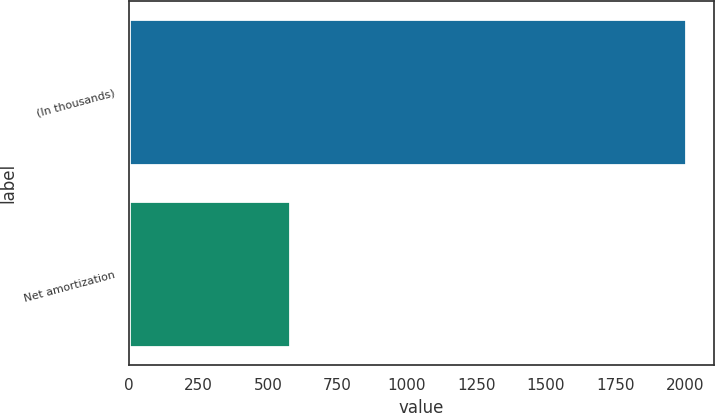<chart> <loc_0><loc_0><loc_500><loc_500><bar_chart><fcel>(In thousands)<fcel>Net amortization<nl><fcel>2003<fcel>580<nl></chart> 